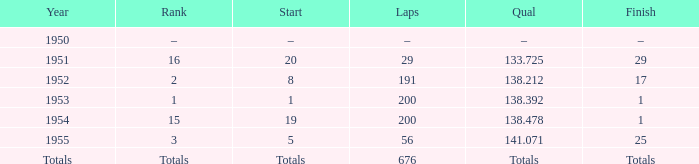How many laps was qualifier of 138.212? 191.0. 